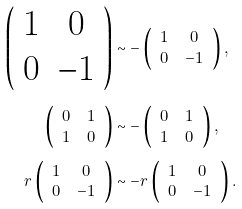<formula> <loc_0><loc_0><loc_500><loc_500>\left ( \begin{array} { c c } 1 & 0 \\ 0 & - 1 \end{array} \right ) & \sim - \left ( \begin{array} { c c } 1 & 0 \\ 0 & - 1 \end{array} \right ) , \\ \left ( \begin{array} { c c } 0 & 1 \\ 1 & 0 \end{array} \right ) & \sim - \left ( \begin{array} { c c } 0 & 1 \\ 1 & 0 \end{array} \right ) , \\ r \left ( \begin{array} { c c } 1 & 0 \\ 0 & - 1 \end{array} \right ) & \sim - r \left ( \begin{array} { c c } 1 & 0 \\ 0 & - 1 \end{array} \right ) .</formula> 